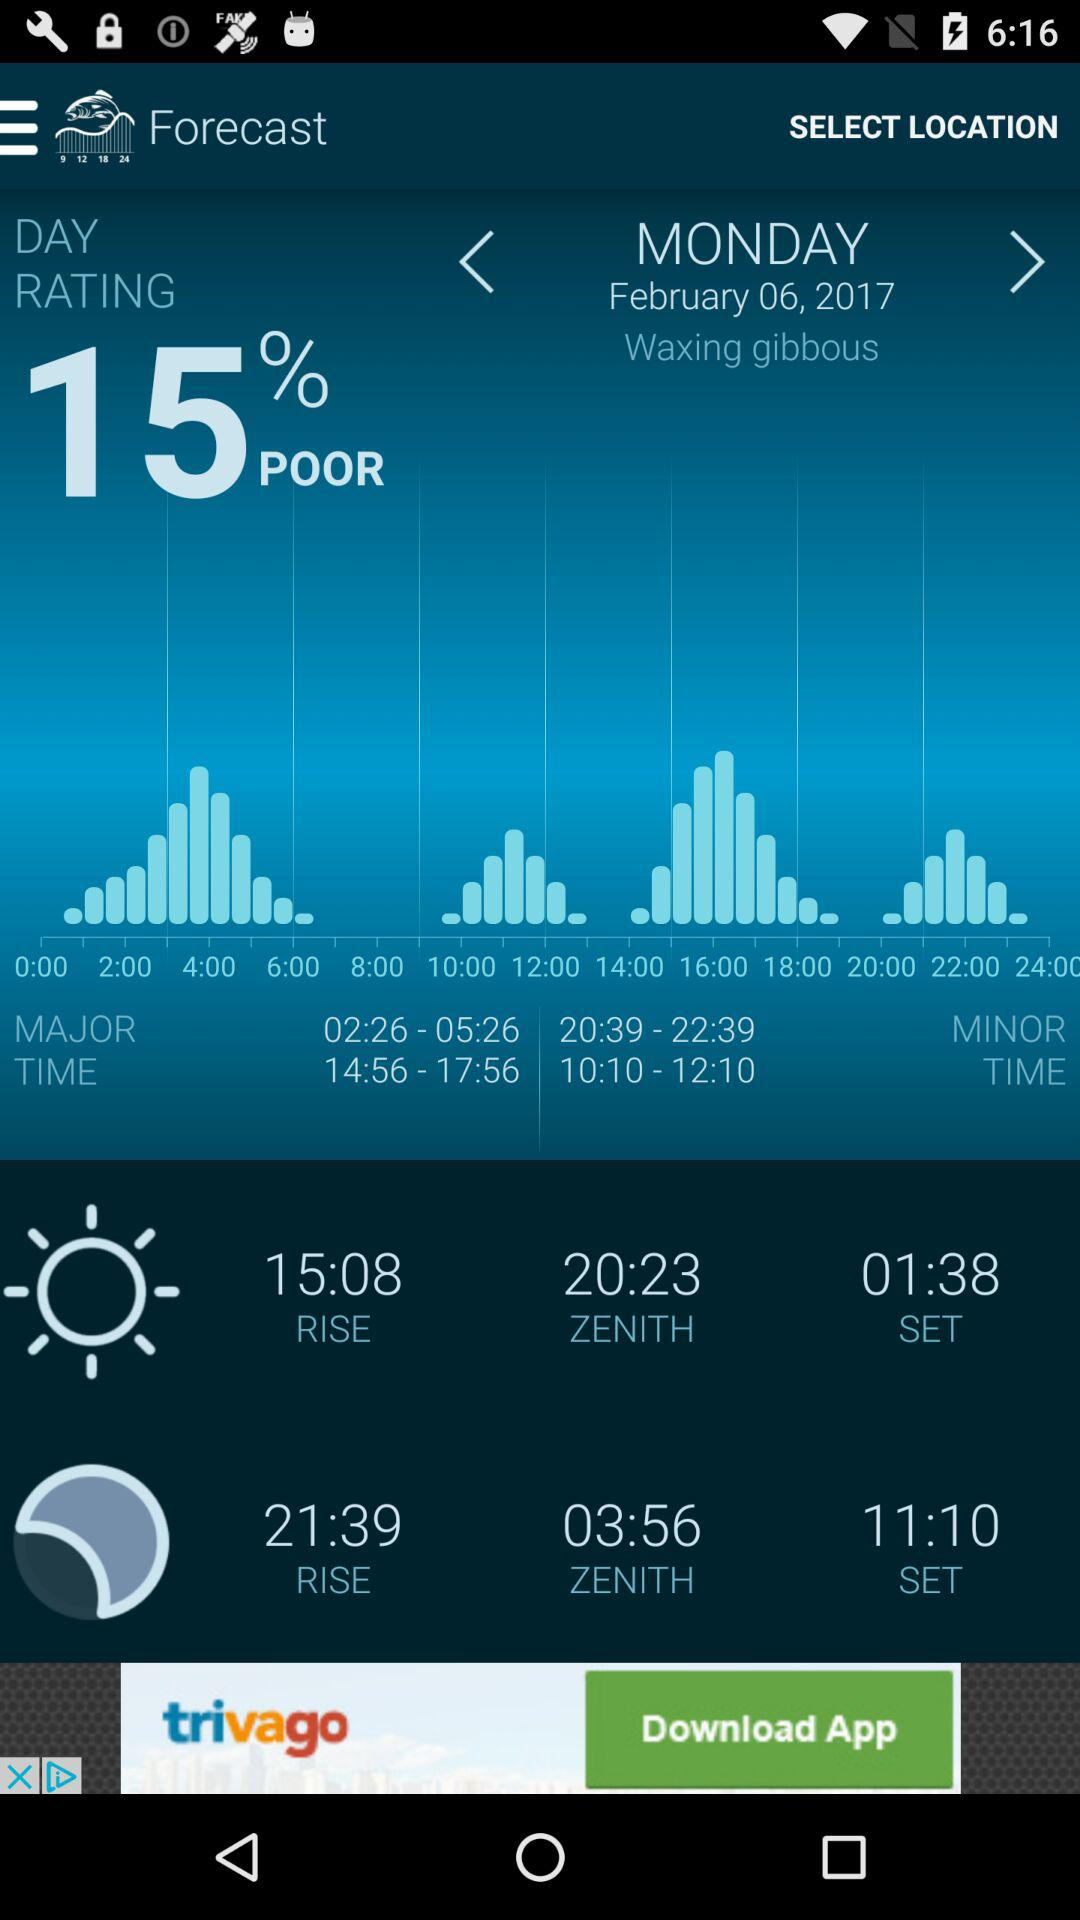What is the given day? The given day is Monday. 